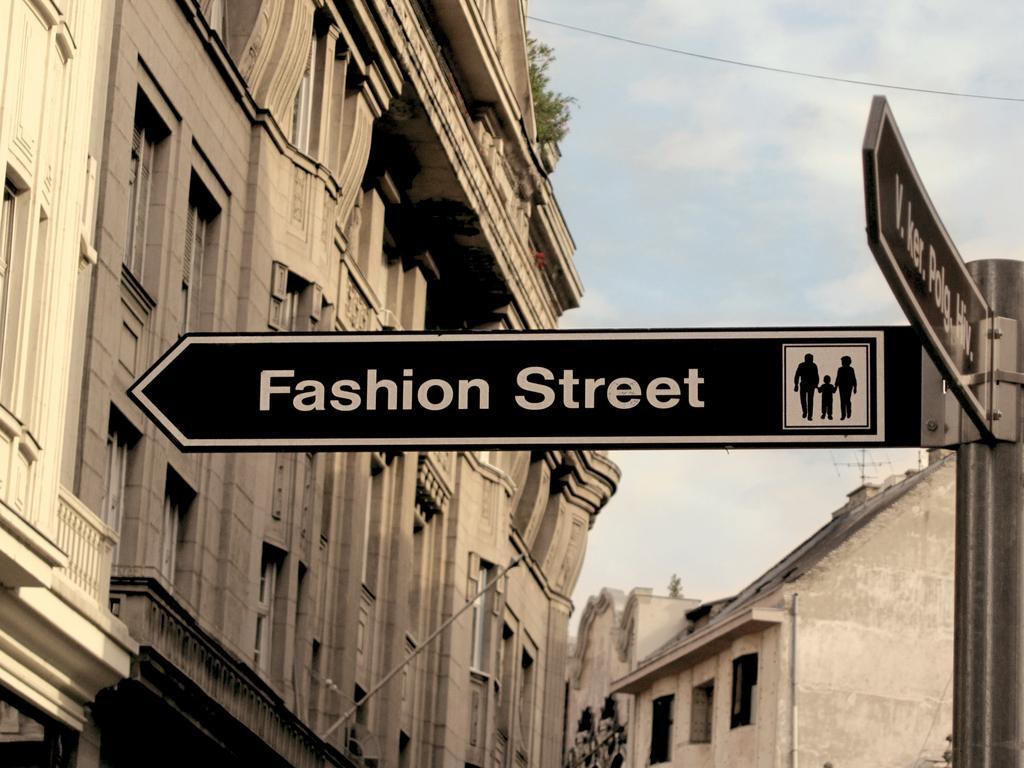Describe this image in one or two sentences. In this image we can see a sign board. Behind the sign board buildings are there. At the right top of the image sky is there with some clouds. 